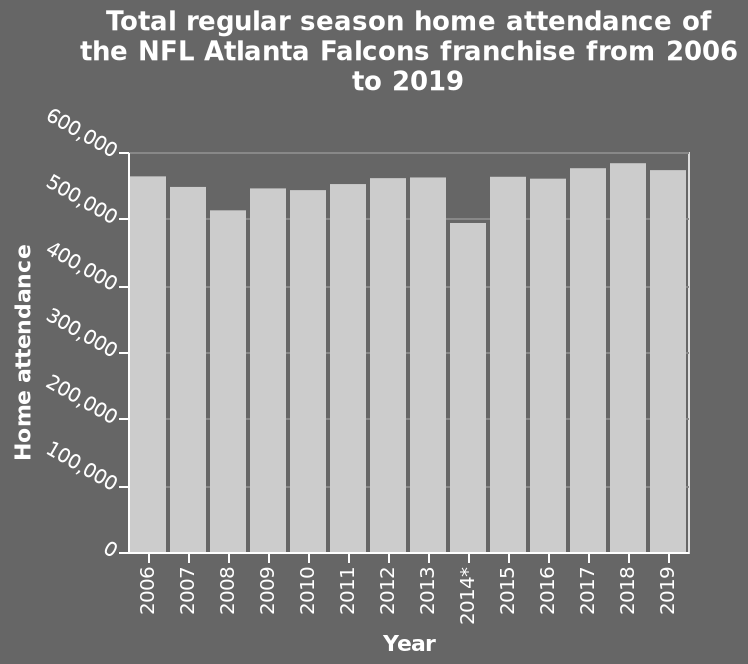<image>
In which year did the NFL Atlanta Falcons franchise have the highest home attendance? The year in which the NFL Atlanta Falcons franchise had the highest home attendance is not provided in the given description. What is the total regular season home attendance for the NFL Atlanta Falcons franchise in 2019? The total regular season home attendance for the NFL Atlanta Falcons franchise in 2019 is not provided in the given description. What was the highest attendance figure for the Atlanta Falcons between 2006 and 2019? The highest attendance figure for the Atlanta Falcons between 2006 and 2019 was not mentioned in the description. What is the range of the y-axis on the bar graph?  The range of the y-axis on the bar graph is from 0 to 600,000. 